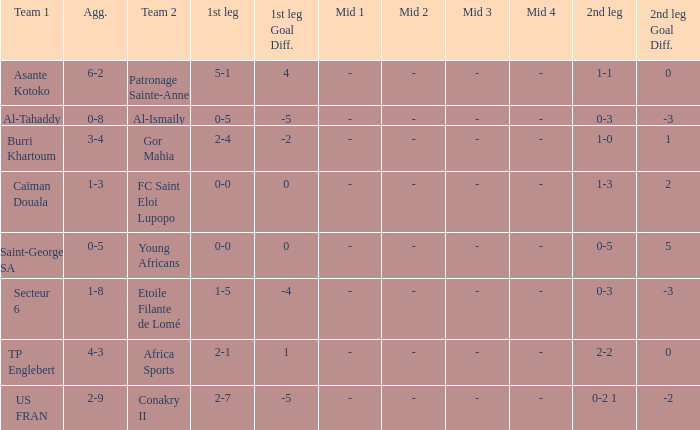Which team lost 0-3 and 0-5? Al-Tahaddy. 